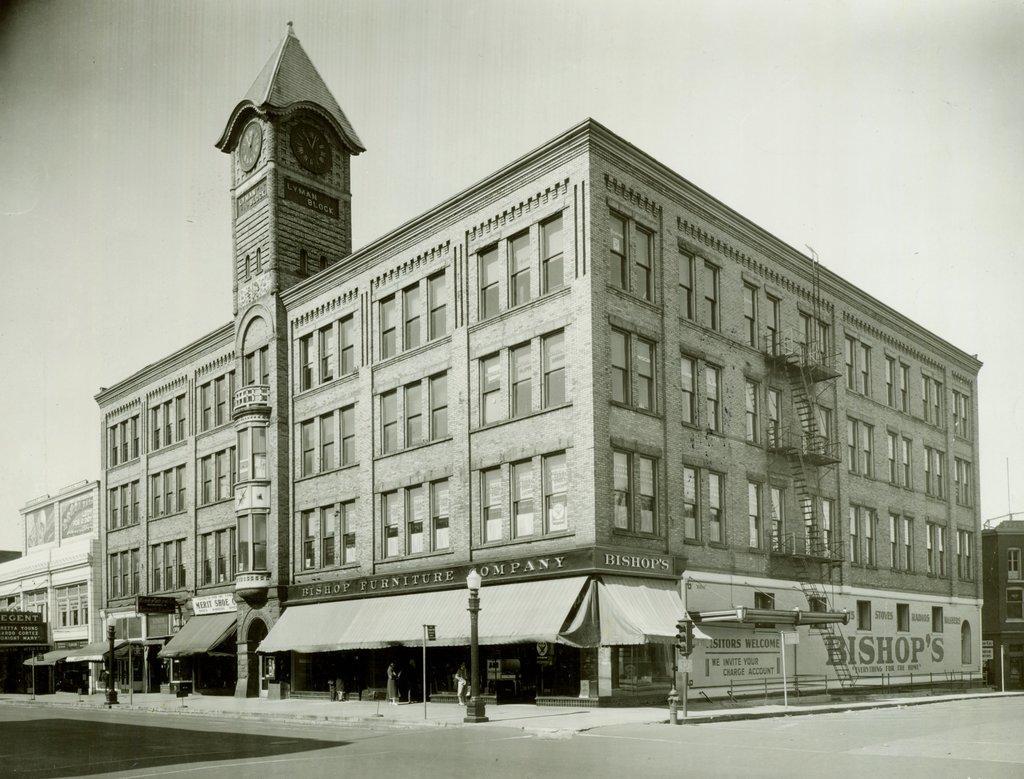How would you summarize this image in a sentence or two? In this picture I can see there is a building and there is a clock attached on the tower. There are some poles here with lamps and the sky is clear. 